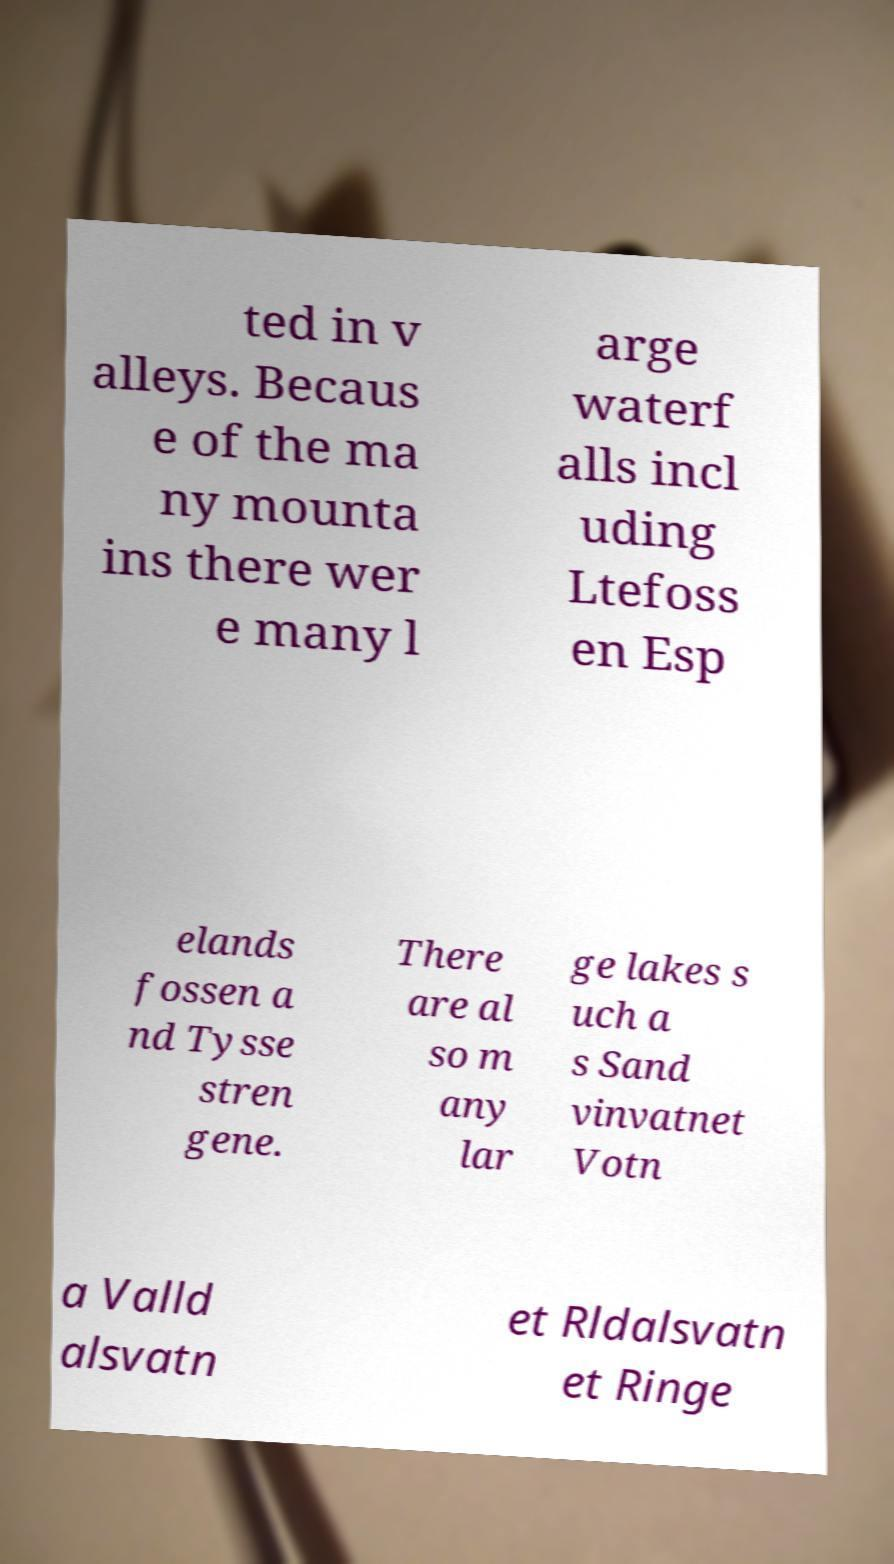What messages or text are displayed in this image? I need them in a readable, typed format. ted in v alleys. Becaus e of the ma ny mounta ins there wer e many l arge waterf alls incl uding Ltefoss en Esp elands fossen a nd Tysse stren gene. There are al so m any lar ge lakes s uch a s Sand vinvatnet Votn a Valld alsvatn et Rldalsvatn et Ringe 